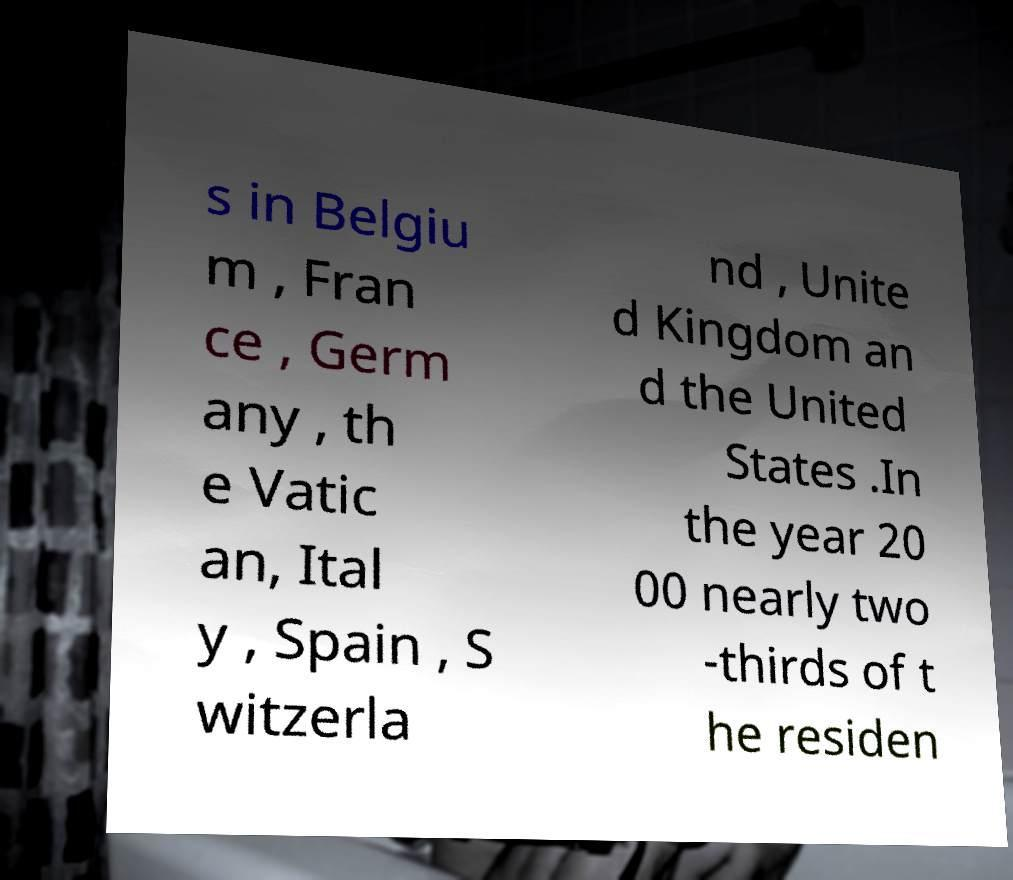For documentation purposes, I need the text within this image transcribed. Could you provide that? s in Belgiu m , Fran ce , Germ any , th e Vatic an, Ital y , Spain , S witzerla nd , Unite d Kingdom an d the United States .In the year 20 00 nearly two -thirds of t he residen 